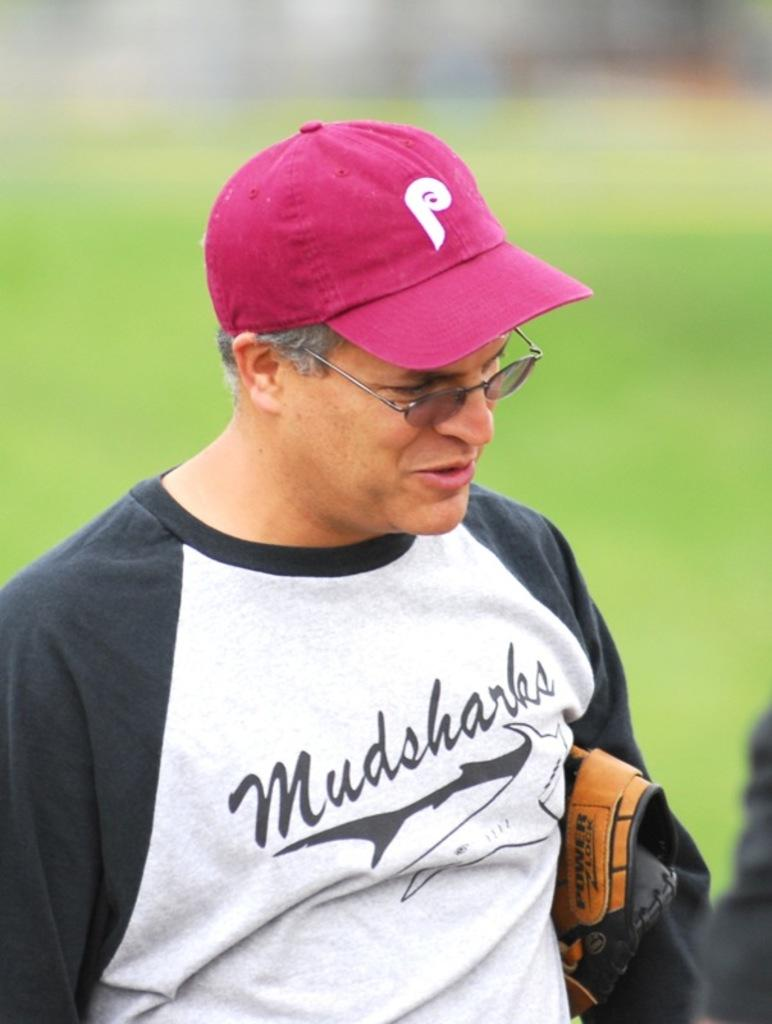Provide a one-sentence caption for the provided image. A man wearing a Mudsharks baseball tee-shirt is clutching his glove under his arm. 